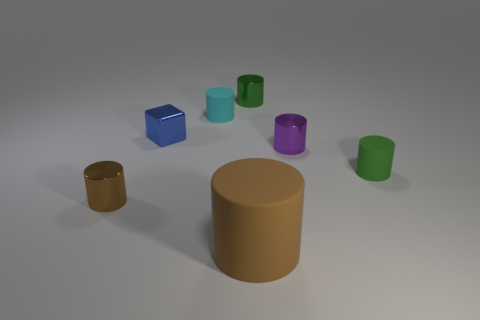Subtract all green matte cylinders. How many cylinders are left? 5 Add 1 large yellow metal objects. How many objects exist? 8 Subtract all yellow balls. How many green cylinders are left? 2 Subtract all brown cylinders. How many cylinders are left? 4 Subtract 1 blocks. How many blocks are left? 0 Subtract all yellow cubes. Subtract all blue spheres. How many cubes are left? 1 Subtract all green matte cylinders. Subtract all blue cubes. How many objects are left? 5 Add 5 tiny purple shiny cylinders. How many tiny purple shiny cylinders are left? 6 Add 5 brown balls. How many brown balls exist? 5 Subtract 0 gray blocks. How many objects are left? 7 